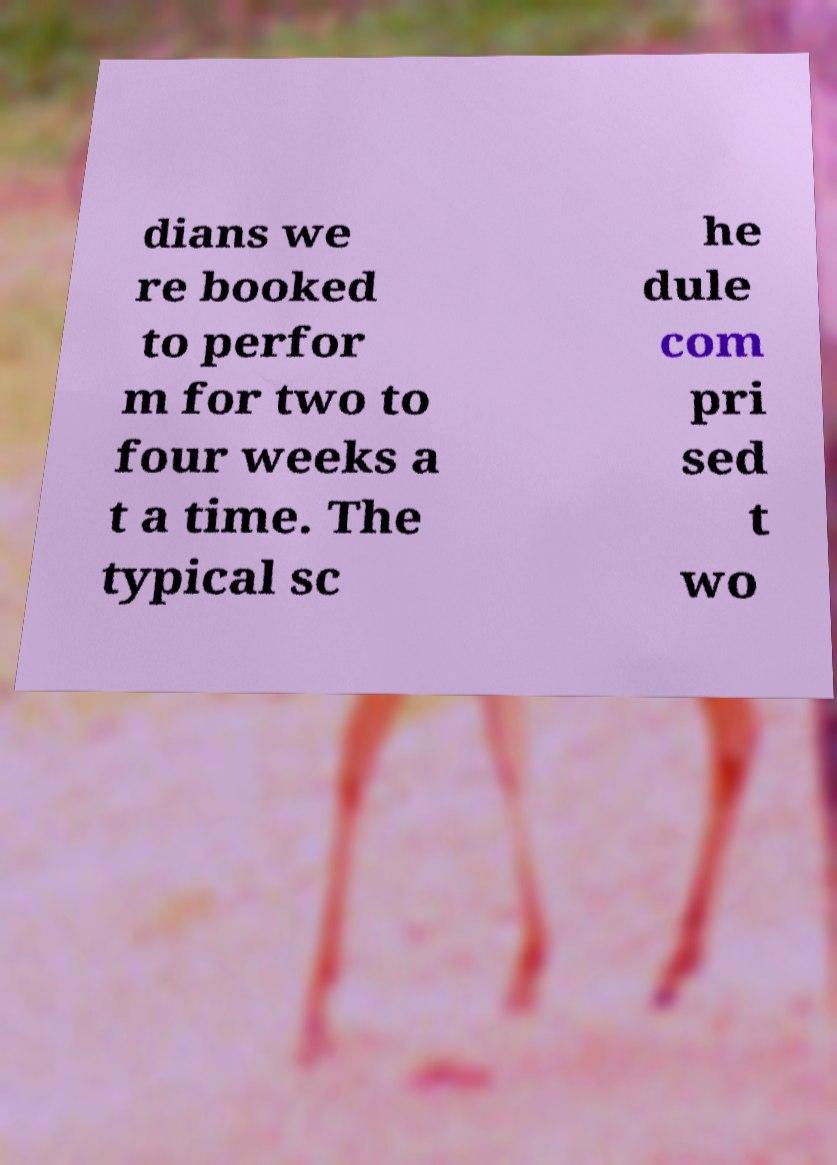I need the written content from this picture converted into text. Can you do that? dians we re booked to perfor m for two to four weeks a t a time. The typical sc he dule com pri sed t wo 